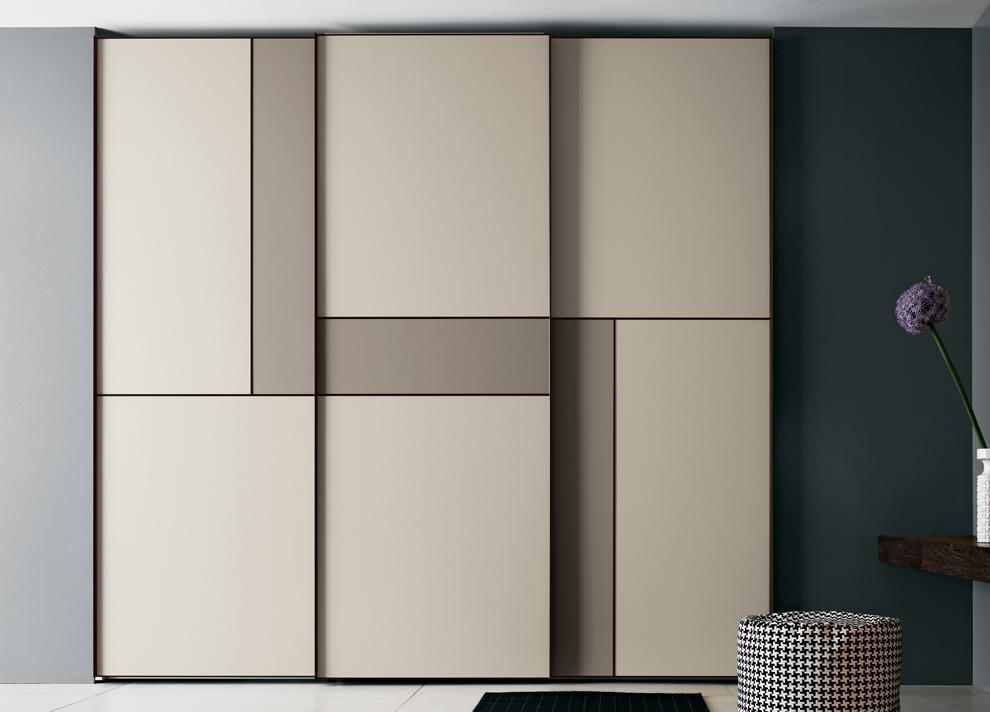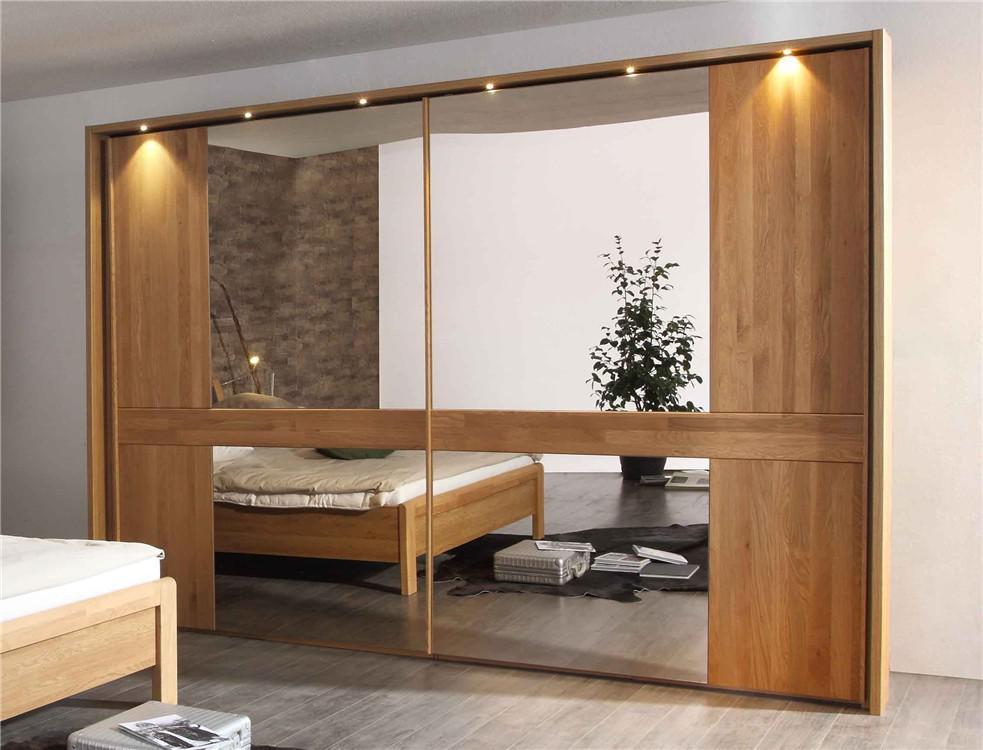The first image is the image on the left, the second image is the image on the right. Assess this claim about the two images: "An image shows a wardrobe with mirror on the right and black panel on the left.". Correct or not? Answer yes or no. No. The first image is the image on the left, the second image is the image on the right. Analyze the images presented: Is the assertion "In one image, a free standing dark gray wardrobe has one mirrored door that reflects the other side of the room." valid? Answer yes or no. No. 